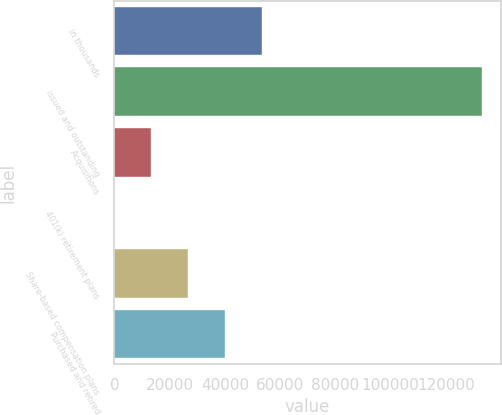Convert chart. <chart><loc_0><loc_0><loc_500><loc_500><bar_chart><fcel>in thousands<fcel>issued and outstanding<fcel>Acquisitions<fcel>401(k) retirement plans<fcel>Share-based compensation plans<fcel>Purchased and retired<nl><fcel>53270.7<fcel>133172<fcel>13320<fcel>3.09<fcel>26636.9<fcel>39953.8<nl></chart> 